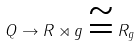Convert formula to latex. <formula><loc_0><loc_0><loc_500><loc_500>Q \to R \rtimes g \cong R _ { g }</formula> 